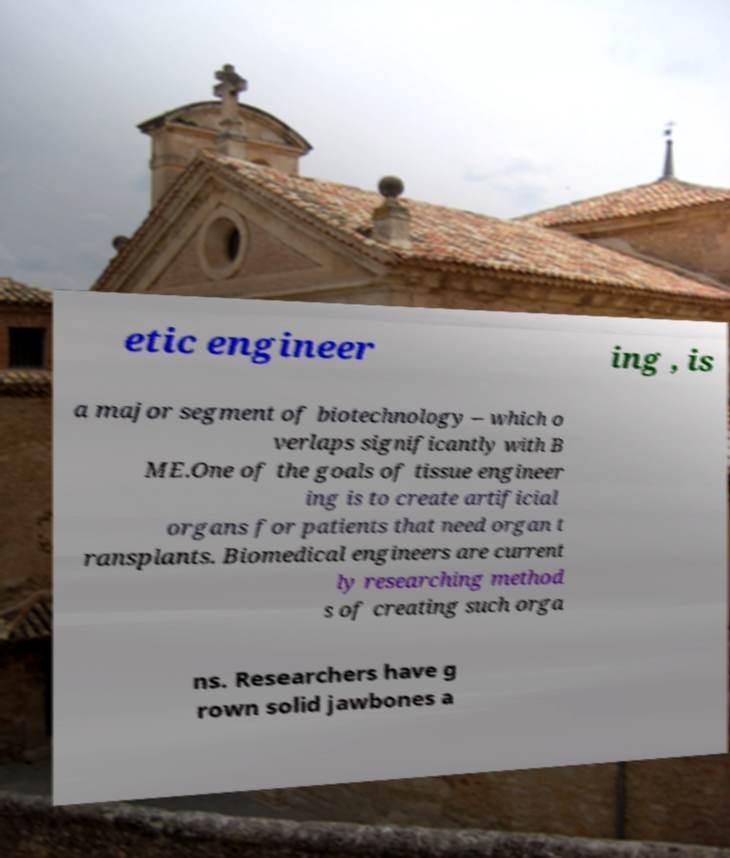For documentation purposes, I need the text within this image transcribed. Could you provide that? etic engineer ing , is a major segment of biotechnology – which o verlaps significantly with B ME.One of the goals of tissue engineer ing is to create artificial organs for patients that need organ t ransplants. Biomedical engineers are current ly researching method s of creating such orga ns. Researchers have g rown solid jawbones a 